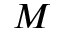Convert formula to latex. <formula><loc_0><loc_0><loc_500><loc_500>M</formula> 